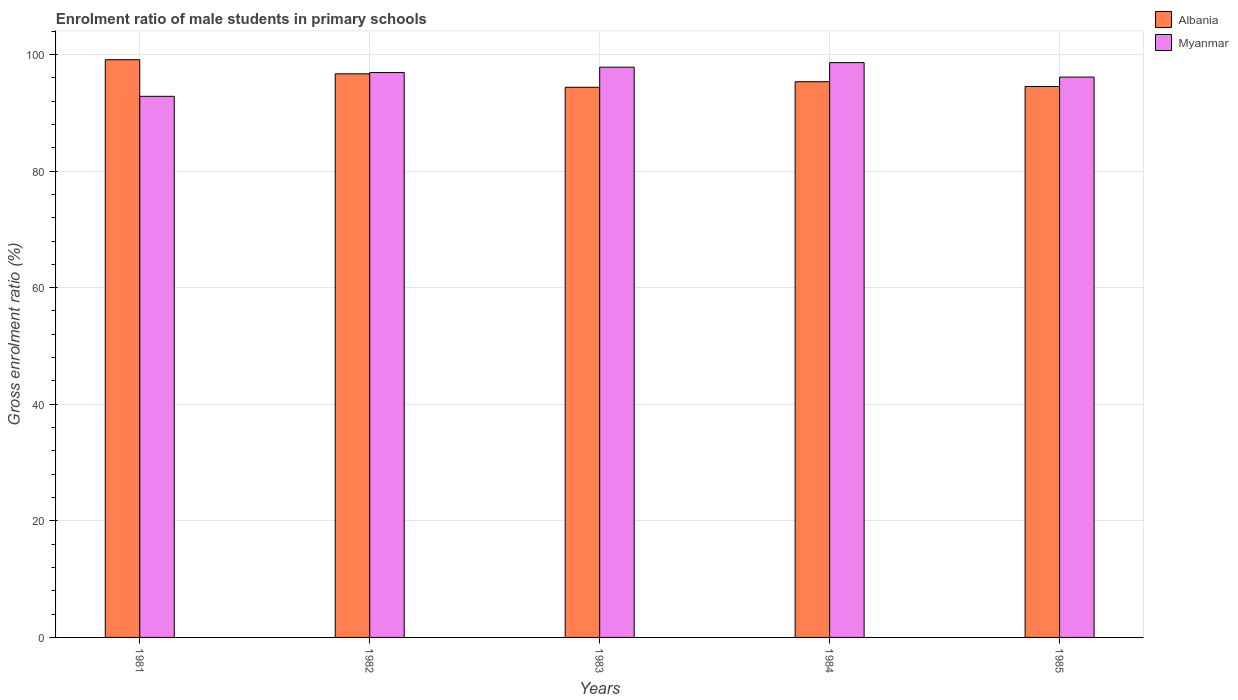How many different coloured bars are there?
Ensure brevity in your answer.  2. Are the number of bars per tick equal to the number of legend labels?
Your response must be concise. Yes. How many bars are there on the 5th tick from the left?
Provide a succinct answer. 2. How many bars are there on the 1st tick from the right?
Give a very brief answer. 2. What is the label of the 3rd group of bars from the left?
Give a very brief answer. 1983. In how many cases, is the number of bars for a given year not equal to the number of legend labels?
Make the answer very short. 0. What is the enrolment ratio of male students in primary schools in Albania in 1982?
Give a very brief answer. 96.68. Across all years, what is the maximum enrolment ratio of male students in primary schools in Albania?
Provide a short and direct response. 99.1. Across all years, what is the minimum enrolment ratio of male students in primary schools in Myanmar?
Keep it short and to the point. 92.82. In which year was the enrolment ratio of male students in primary schools in Myanmar maximum?
Provide a succinct answer. 1984. What is the total enrolment ratio of male students in primary schools in Myanmar in the graph?
Offer a terse response. 482.25. What is the difference between the enrolment ratio of male students in primary schools in Myanmar in 1982 and that in 1985?
Keep it short and to the point. 0.78. What is the difference between the enrolment ratio of male students in primary schools in Myanmar in 1981 and the enrolment ratio of male students in primary schools in Albania in 1982?
Offer a very short reply. -3.86. What is the average enrolment ratio of male students in primary schools in Myanmar per year?
Provide a succinct answer. 96.45. In the year 1981, what is the difference between the enrolment ratio of male students in primary schools in Albania and enrolment ratio of male students in primary schools in Myanmar?
Offer a very short reply. 6.28. In how many years, is the enrolment ratio of male students in primary schools in Myanmar greater than 44 %?
Make the answer very short. 5. What is the ratio of the enrolment ratio of male students in primary schools in Myanmar in 1981 to that in 1983?
Ensure brevity in your answer.  0.95. What is the difference between the highest and the second highest enrolment ratio of male students in primary schools in Myanmar?
Make the answer very short. 0.79. What is the difference between the highest and the lowest enrolment ratio of male students in primary schools in Albania?
Your response must be concise. 4.73. In how many years, is the enrolment ratio of male students in primary schools in Myanmar greater than the average enrolment ratio of male students in primary schools in Myanmar taken over all years?
Provide a succinct answer. 3. What does the 1st bar from the left in 1983 represents?
Ensure brevity in your answer.  Albania. What does the 1st bar from the right in 1983 represents?
Your response must be concise. Myanmar. Are all the bars in the graph horizontal?
Provide a short and direct response. No. Are the values on the major ticks of Y-axis written in scientific E-notation?
Offer a very short reply. No. Does the graph contain grids?
Offer a terse response. Yes. How many legend labels are there?
Offer a very short reply. 2. What is the title of the graph?
Provide a succinct answer. Enrolment ratio of male students in primary schools. Does "Bangladesh" appear as one of the legend labels in the graph?
Your response must be concise. No. What is the Gross enrolment ratio (%) of Albania in 1981?
Provide a short and direct response. 99.1. What is the Gross enrolment ratio (%) in Myanmar in 1981?
Offer a very short reply. 92.82. What is the Gross enrolment ratio (%) in Albania in 1982?
Offer a terse response. 96.68. What is the Gross enrolment ratio (%) of Myanmar in 1982?
Your answer should be compact. 96.89. What is the Gross enrolment ratio (%) of Albania in 1983?
Offer a very short reply. 94.37. What is the Gross enrolment ratio (%) in Myanmar in 1983?
Keep it short and to the point. 97.82. What is the Gross enrolment ratio (%) in Albania in 1984?
Ensure brevity in your answer.  95.33. What is the Gross enrolment ratio (%) in Myanmar in 1984?
Keep it short and to the point. 98.6. What is the Gross enrolment ratio (%) of Albania in 1985?
Provide a short and direct response. 94.51. What is the Gross enrolment ratio (%) in Myanmar in 1985?
Your answer should be very brief. 96.12. Across all years, what is the maximum Gross enrolment ratio (%) of Albania?
Provide a succinct answer. 99.1. Across all years, what is the maximum Gross enrolment ratio (%) of Myanmar?
Provide a short and direct response. 98.6. Across all years, what is the minimum Gross enrolment ratio (%) in Albania?
Your answer should be compact. 94.37. Across all years, what is the minimum Gross enrolment ratio (%) of Myanmar?
Provide a succinct answer. 92.82. What is the total Gross enrolment ratio (%) of Albania in the graph?
Your response must be concise. 479.98. What is the total Gross enrolment ratio (%) of Myanmar in the graph?
Provide a short and direct response. 482.25. What is the difference between the Gross enrolment ratio (%) of Albania in 1981 and that in 1982?
Your answer should be very brief. 2.42. What is the difference between the Gross enrolment ratio (%) in Myanmar in 1981 and that in 1982?
Your answer should be very brief. -4.07. What is the difference between the Gross enrolment ratio (%) of Albania in 1981 and that in 1983?
Make the answer very short. 4.73. What is the difference between the Gross enrolment ratio (%) of Myanmar in 1981 and that in 1983?
Provide a succinct answer. -5. What is the difference between the Gross enrolment ratio (%) in Albania in 1981 and that in 1984?
Keep it short and to the point. 3.77. What is the difference between the Gross enrolment ratio (%) in Myanmar in 1981 and that in 1984?
Offer a terse response. -5.78. What is the difference between the Gross enrolment ratio (%) of Albania in 1981 and that in 1985?
Provide a short and direct response. 4.59. What is the difference between the Gross enrolment ratio (%) of Myanmar in 1981 and that in 1985?
Offer a very short reply. -3.3. What is the difference between the Gross enrolment ratio (%) of Albania in 1982 and that in 1983?
Your answer should be compact. 2.31. What is the difference between the Gross enrolment ratio (%) in Myanmar in 1982 and that in 1983?
Make the answer very short. -0.92. What is the difference between the Gross enrolment ratio (%) of Albania in 1982 and that in 1984?
Provide a succinct answer. 1.36. What is the difference between the Gross enrolment ratio (%) of Myanmar in 1982 and that in 1984?
Ensure brevity in your answer.  -1.71. What is the difference between the Gross enrolment ratio (%) in Albania in 1982 and that in 1985?
Ensure brevity in your answer.  2.17. What is the difference between the Gross enrolment ratio (%) in Myanmar in 1982 and that in 1985?
Your response must be concise. 0.78. What is the difference between the Gross enrolment ratio (%) of Albania in 1983 and that in 1984?
Ensure brevity in your answer.  -0.96. What is the difference between the Gross enrolment ratio (%) of Myanmar in 1983 and that in 1984?
Your answer should be very brief. -0.79. What is the difference between the Gross enrolment ratio (%) in Albania in 1983 and that in 1985?
Make the answer very short. -0.14. What is the difference between the Gross enrolment ratio (%) of Myanmar in 1983 and that in 1985?
Provide a short and direct response. 1.7. What is the difference between the Gross enrolment ratio (%) in Albania in 1984 and that in 1985?
Ensure brevity in your answer.  0.82. What is the difference between the Gross enrolment ratio (%) in Myanmar in 1984 and that in 1985?
Make the answer very short. 2.48. What is the difference between the Gross enrolment ratio (%) in Albania in 1981 and the Gross enrolment ratio (%) in Myanmar in 1982?
Your answer should be compact. 2.21. What is the difference between the Gross enrolment ratio (%) in Albania in 1981 and the Gross enrolment ratio (%) in Myanmar in 1983?
Give a very brief answer. 1.28. What is the difference between the Gross enrolment ratio (%) of Albania in 1981 and the Gross enrolment ratio (%) of Myanmar in 1984?
Make the answer very short. 0.5. What is the difference between the Gross enrolment ratio (%) in Albania in 1981 and the Gross enrolment ratio (%) in Myanmar in 1985?
Make the answer very short. 2.98. What is the difference between the Gross enrolment ratio (%) in Albania in 1982 and the Gross enrolment ratio (%) in Myanmar in 1983?
Your answer should be compact. -1.13. What is the difference between the Gross enrolment ratio (%) in Albania in 1982 and the Gross enrolment ratio (%) in Myanmar in 1984?
Make the answer very short. -1.92. What is the difference between the Gross enrolment ratio (%) of Albania in 1982 and the Gross enrolment ratio (%) of Myanmar in 1985?
Give a very brief answer. 0.56. What is the difference between the Gross enrolment ratio (%) of Albania in 1983 and the Gross enrolment ratio (%) of Myanmar in 1984?
Your answer should be very brief. -4.23. What is the difference between the Gross enrolment ratio (%) in Albania in 1983 and the Gross enrolment ratio (%) in Myanmar in 1985?
Give a very brief answer. -1.75. What is the difference between the Gross enrolment ratio (%) of Albania in 1984 and the Gross enrolment ratio (%) of Myanmar in 1985?
Your response must be concise. -0.79. What is the average Gross enrolment ratio (%) of Albania per year?
Offer a terse response. 96. What is the average Gross enrolment ratio (%) of Myanmar per year?
Provide a short and direct response. 96.45. In the year 1981, what is the difference between the Gross enrolment ratio (%) in Albania and Gross enrolment ratio (%) in Myanmar?
Keep it short and to the point. 6.28. In the year 1982, what is the difference between the Gross enrolment ratio (%) of Albania and Gross enrolment ratio (%) of Myanmar?
Keep it short and to the point. -0.21. In the year 1983, what is the difference between the Gross enrolment ratio (%) in Albania and Gross enrolment ratio (%) in Myanmar?
Offer a very short reply. -3.45. In the year 1984, what is the difference between the Gross enrolment ratio (%) of Albania and Gross enrolment ratio (%) of Myanmar?
Give a very brief answer. -3.27. In the year 1985, what is the difference between the Gross enrolment ratio (%) of Albania and Gross enrolment ratio (%) of Myanmar?
Your answer should be very brief. -1.61. What is the ratio of the Gross enrolment ratio (%) of Myanmar in 1981 to that in 1982?
Give a very brief answer. 0.96. What is the ratio of the Gross enrolment ratio (%) in Albania in 1981 to that in 1983?
Your answer should be compact. 1.05. What is the ratio of the Gross enrolment ratio (%) in Myanmar in 1981 to that in 1983?
Provide a succinct answer. 0.95. What is the ratio of the Gross enrolment ratio (%) of Albania in 1981 to that in 1984?
Your answer should be compact. 1.04. What is the ratio of the Gross enrolment ratio (%) of Myanmar in 1981 to that in 1984?
Your answer should be compact. 0.94. What is the ratio of the Gross enrolment ratio (%) in Albania in 1981 to that in 1985?
Offer a terse response. 1.05. What is the ratio of the Gross enrolment ratio (%) in Myanmar in 1981 to that in 1985?
Your answer should be compact. 0.97. What is the ratio of the Gross enrolment ratio (%) in Albania in 1982 to that in 1983?
Your answer should be compact. 1.02. What is the ratio of the Gross enrolment ratio (%) of Myanmar in 1982 to that in 1983?
Offer a very short reply. 0.99. What is the ratio of the Gross enrolment ratio (%) of Albania in 1982 to that in 1984?
Your answer should be very brief. 1.01. What is the ratio of the Gross enrolment ratio (%) in Myanmar in 1982 to that in 1984?
Make the answer very short. 0.98. What is the ratio of the Gross enrolment ratio (%) in Albania in 1982 to that in 1985?
Your response must be concise. 1.02. What is the ratio of the Gross enrolment ratio (%) in Albania in 1983 to that in 1984?
Provide a succinct answer. 0.99. What is the ratio of the Gross enrolment ratio (%) of Myanmar in 1983 to that in 1984?
Your answer should be very brief. 0.99. What is the ratio of the Gross enrolment ratio (%) in Albania in 1983 to that in 1985?
Make the answer very short. 1. What is the ratio of the Gross enrolment ratio (%) in Myanmar in 1983 to that in 1985?
Your response must be concise. 1.02. What is the ratio of the Gross enrolment ratio (%) in Albania in 1984 to that in 1985?
Your response must be concise. 1.01. What is the ratio of the Gross enrolment ratio (%) in Myanmar in 1984 to that in 1985?
Keep it short and to the point. 1.03. What is the difference between the highest and the second highest Gross enrolment ratio (%) of Albania?
Offer a terse response. 2.42. What is the difference between the highest and the second highest Gross enrolment ratio (%) in Myanmar?
Keep it short and to the point. 0.79. What is the difference between the highest and the lowest Gross enrolment ratio (%) of Albania?
Your answer should be compact. 4.73. What is the difference between the highest and the lowest Gross enrolment ratio (%) in Myanmar?
Offer a terse response. 5.78. 